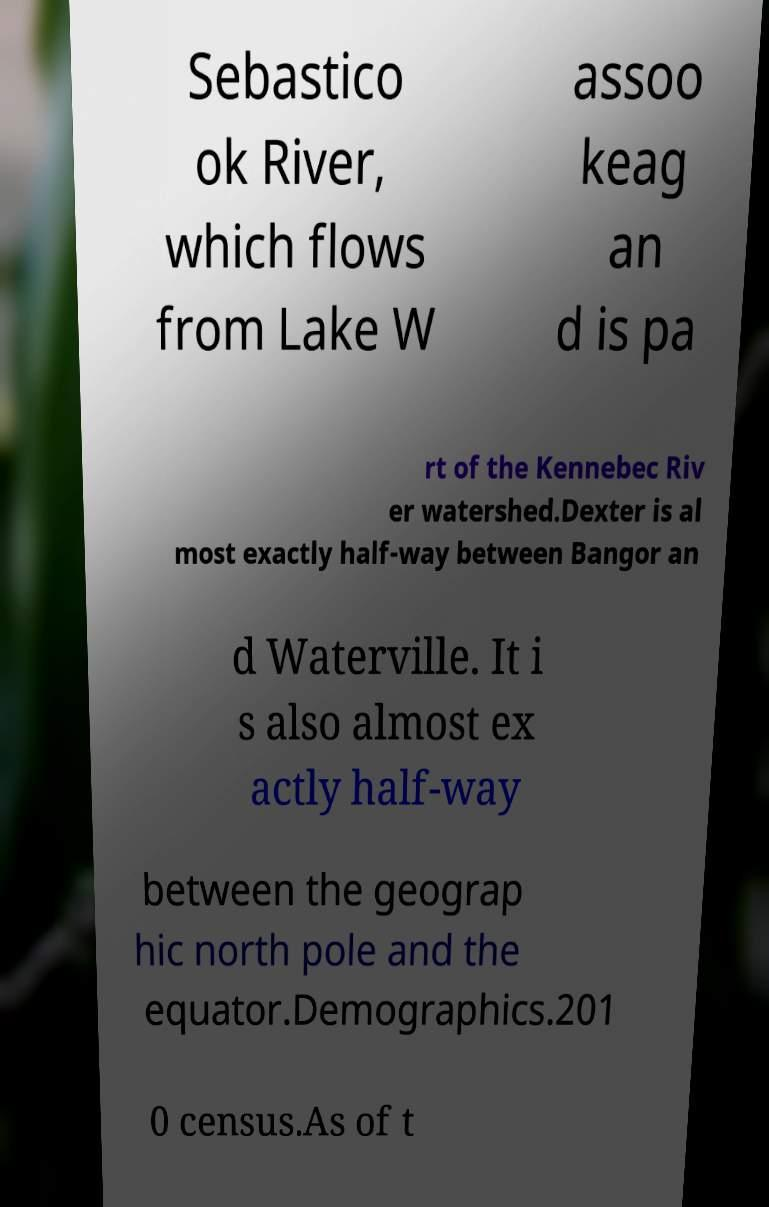There's text embedded in this image that I need extracted. Can you transcribe it verbatim? Sebastico ok River, which flows from Lake W assoo keag an d is pa rt of the Kennebec Riv er watershed.Dexter is al most exactly half-way between Bangor an d Waterville. It i s also almost ex actly half-way between the geograp hic north pole and the equator.Demographics.201 0 census.As of t 